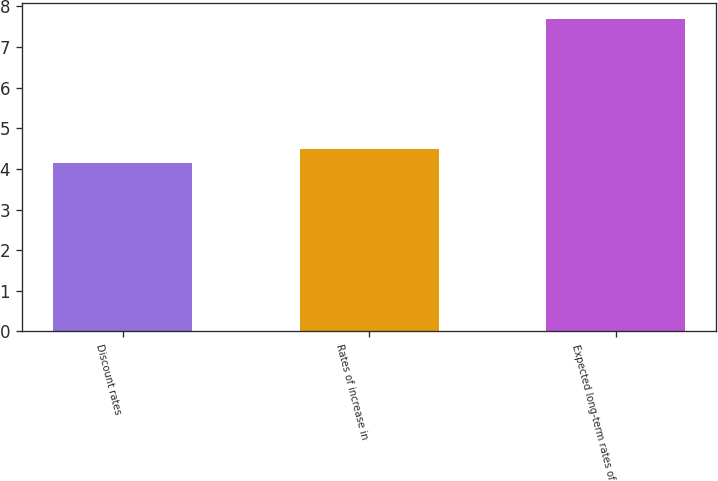Convert chart to OTSL. <chart><loc_0><loc_0><loc_500><loc_500><bar_chart><fcel>Discount rates<fcel>Rates of increase in<fcel>Expected long-term rates of<nl><fcel>4.15<fcel>4.5<fcel>7.69<nl></chart> 